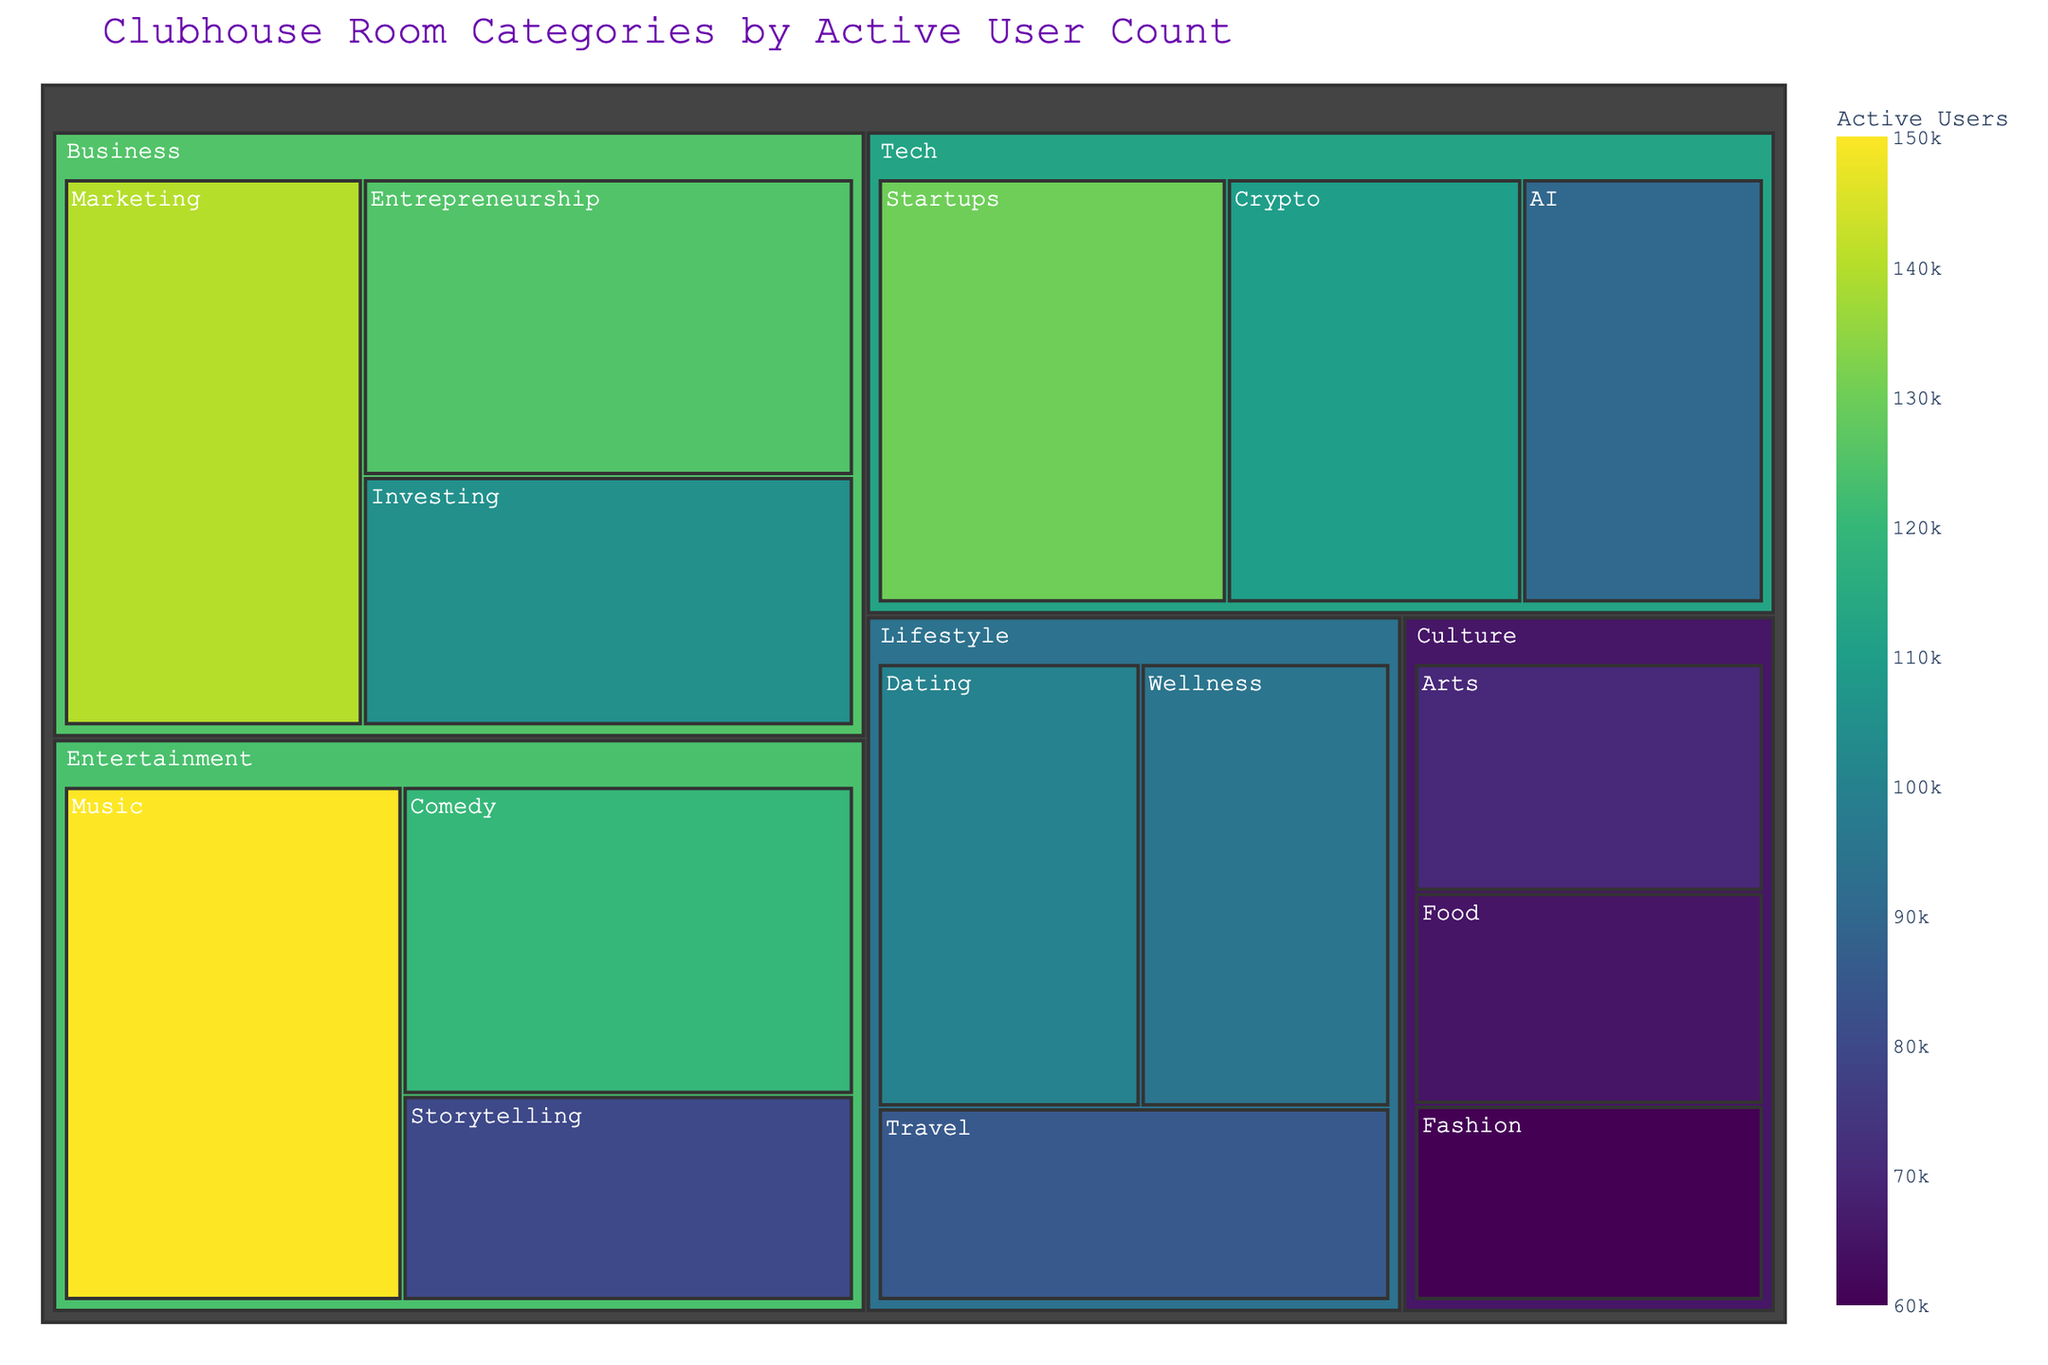What is the title of the figure? The title of the figure is prominently displayed at the top. It reads "Clubhouse Room Categories by Active User Count".
Answer: Clubhouse Room Categories by Active User Count Which subcategory within the Tech category has the highest user count? Within the Tech category, the subcategories are Startups, Crypto, and AI. Startups has 130,000 users, Crypto has 110,000 users, and AI has 90,000 users. Startups have the highest user count.
Answer: Startups What is the total number of active users in the Entertainment category? The Entertainment category includes Music, Comedy, and Storytelling subcategories with user counts of 150,000, 120,000, and 80,000, respectively. Summing these values gives 150,000 + 120,000 + 80,000 = 350,000.
Answer: 350,000 Which main category has the smallest total user count? The main categories and their total user counts are as follows: Entertainment (350,000), Tech (330,000), Lifestyle (280,000), Business (370,000), Culture (195,000). Culture has the smallest total user count.
Answer: Culture How many subcategories are included in the Business category? The Business category consists of Marketing, Entrepreneurship, and Investing. This gives a total of 3 subcategories.
Answer: 3 What is the combined user count for the Music and AI subcategories? The Music subcategory has 150,000 users, and the AI subcategory has 90,000 users. Their combined user count is 150,000 + 90,000 = 240,000.
Answer: 240,000 Which main category has more users: Lifestyle or Tech? The Lifestyle category has a total of 100,000 (Dating) + 95,000 (Wellness) + 85,000 (Travel) = 280,000 users. The Tech category has a total of 130,000 (Startups) + 110,000 (Crypto) + 90,000 (AI) = 330,000 users. Tech has more users than Lifestyle.
Answer: Tech Compare the user count of the Wellness subcategory to the Fashion subcategory. Which has more users? The Wellness subcategory has 95,000 users, while the Fashion subcategory has 60,000 users. Wellness has more users than Fashion.
Answer: Wellness What is the difference in user count between the Comedy and Investing subcategories? The Comedy subcategory has 120,000 users, and the Investing subcategory has 105,000 users. The difference in user count is 120,000 - 105,000 = 15,000.
Answer: 15,000 What percentage of users in the Business category are in the Marketing subcategory? The total user count for the Business category is 140,000 (Marketing) + 125,000 (Entrepreneurship) + 105,000 (Investing) = 370,000. The percentage of users in Marketing is (140,000 / 370,000) * 100 ≈ 37.84%.
Answer: 37.84% 